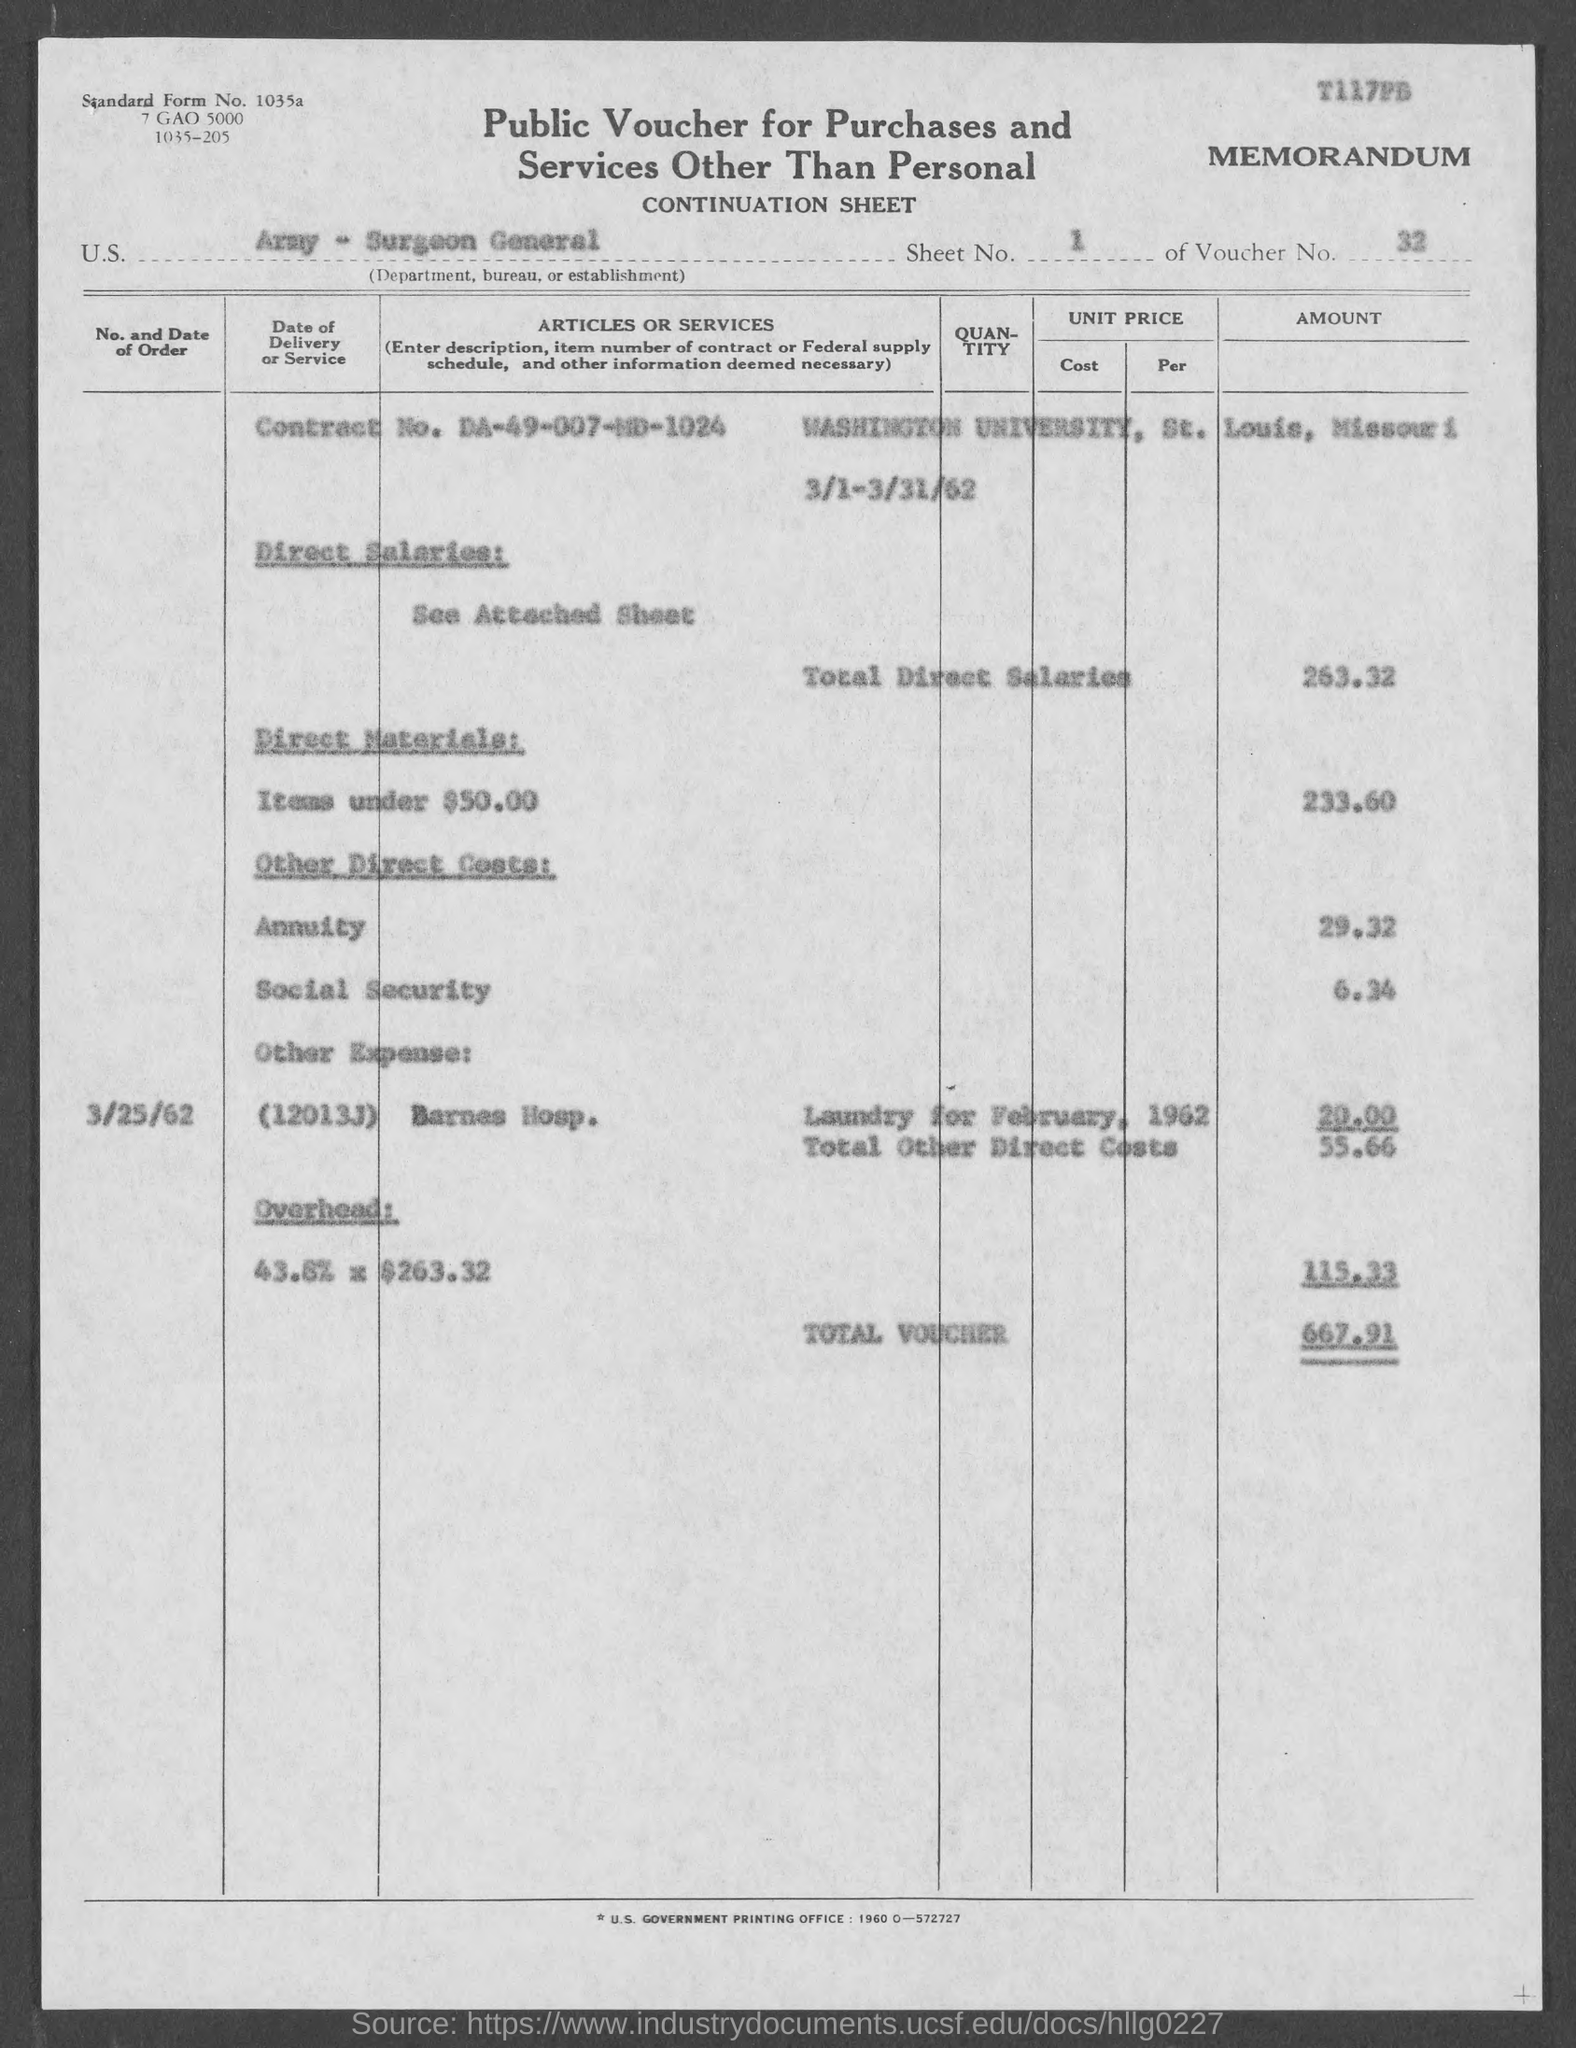Highlight a few significant elements in this photo. The cost for social security is 6.34... The cost for an annuity is 29.32. The total voucher is 667.91. The date of the order for Barnes Hospital is March 25, 1962. The total Direct salaries are approximately 263.32. 